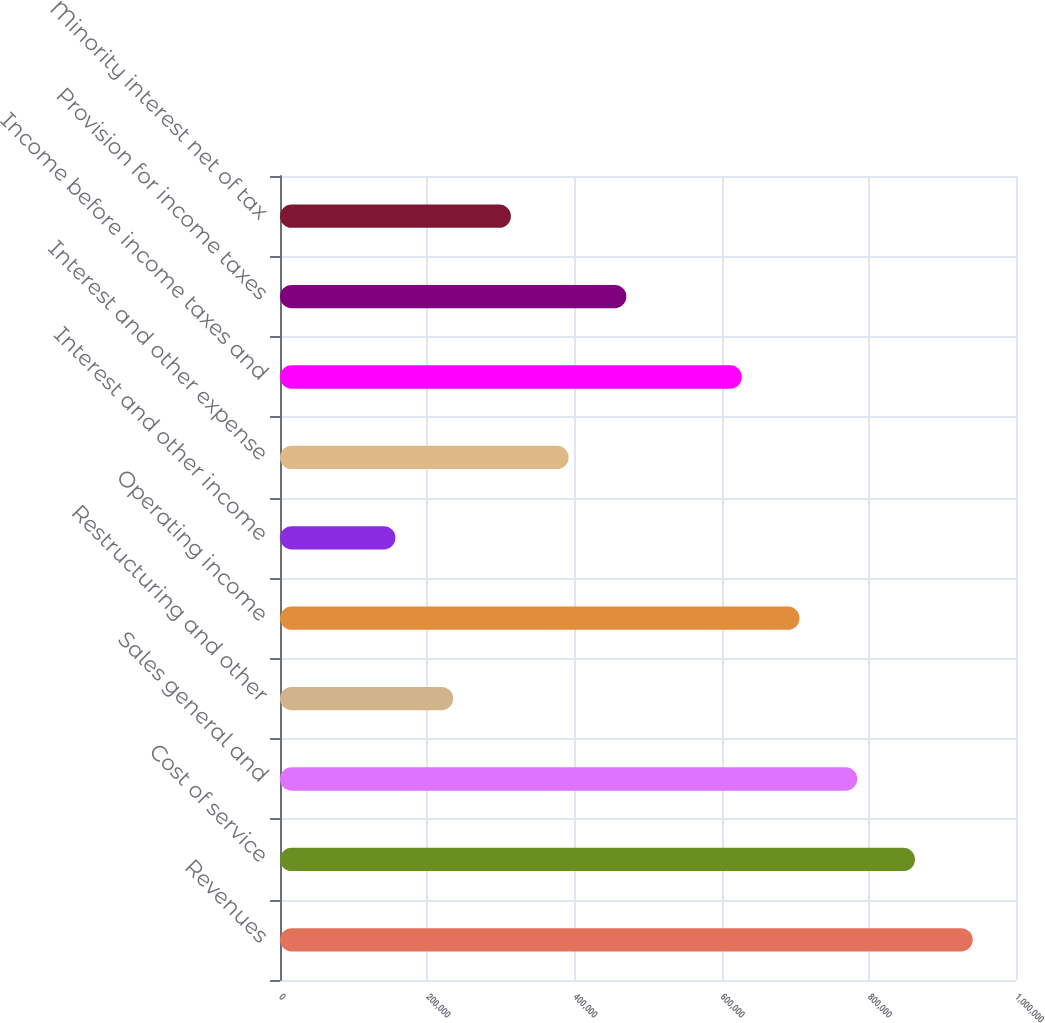Convert chart. <chart><loc_0><loc_0><loc_500><loc_500><bar_chart><fcel>Revenues<fcel>Cost of service<fcel>Sales general and<fcel>Restructuring and other<fcel>Operating income<fcel>Interest and other income<fcel>Interest and other expense<fcel>Income before income taxes and<fcel>Provision for income taxes<fcel>Minority interest net of tax<nl><fcel>941197<fcel>862764<fcel>784331<fcel>235300<fcel>705898<fcel>156867<fcel>392166<fcel>627465<fcel>470599<fcel>313733<nl></chart> 